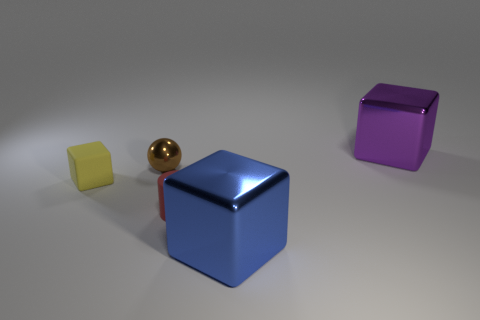What number of big purple shiny objects are on the left side of the tiny yellow rubber block?
Provide a succinct answer. 0. Are there any red cylinders made of the same material as the tiny brown sphere?
Make the answer very short. No. What is the color of the big metallic block in front of the matte cylinder?
Offer a very short reply. Blue. Is the number of blue metal cubes that are to the right of the big purple shiny thing the same as the number of brown things that are in front of the tiny cylinder?
Offer a very short reply. Yes. There is a big thing behind the shiny thing left of the tiny matte cylinder; what is it made of?
Make the answer very short. Metal. How many objects are either large yellow metal cubes or things on the right side of the rubber cylinder?
Offer a very short reply. 2. There is a red cylinder that is the same material as the yellow cube; what is its size?
Provide a succinct answer. Small. Are there more matte objects that are left of the blue metallic object than large brown cylinders?
Provide a succinct answer. Yes. There is a thing that is both behind the tiny yellow rubber object and to the right of the metal sphere; what size is it?
Offer a terse response. Large. There is another large object that is the same shape as the purple thing; what is it made of?
Ensure brevity in your answer.  Metal. 